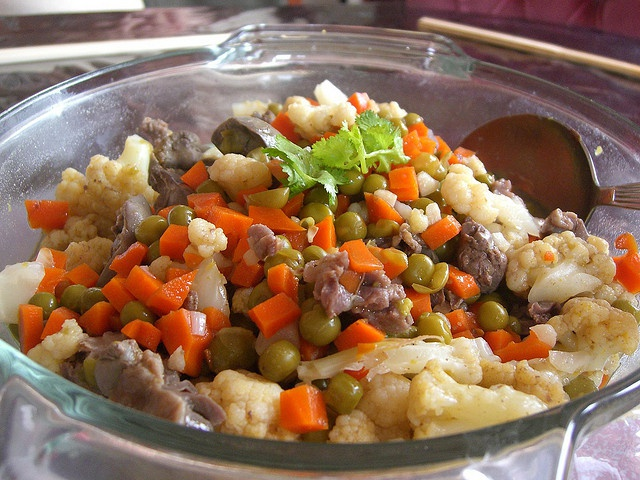Describe the objects in this image and their specific colors. I can see bowl in darkgray, maroon, gray, and brown tones, carrot in darkgray, brown, red, and maroon tones, spoon in darkgray, maroon, black, and gray tones, and carrot in darkgray, brown, red, and maroon tones in this image. 